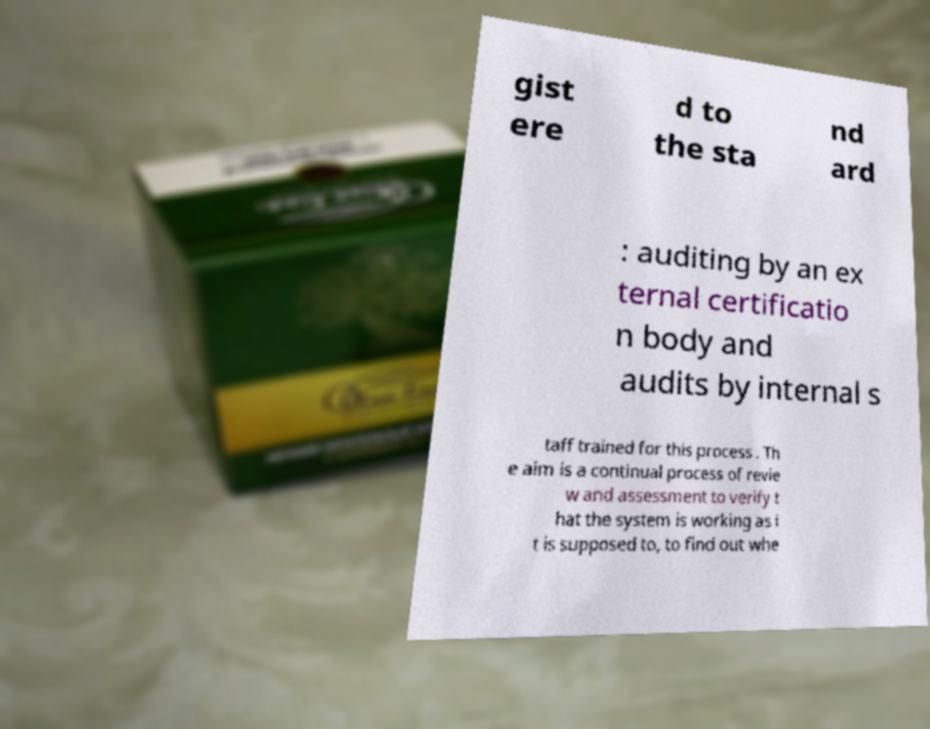There's text embedded in this image that I need extracted. Can you transcribe it verbatim? gist ere d to the sta nd ard : auditing by an ex ternal certificatio n body and audits by internal s taff trained for this process . Th e aim is a continual process of revie w and assessment to verify t hat the system is working as i t is supposed to, to find out whe 